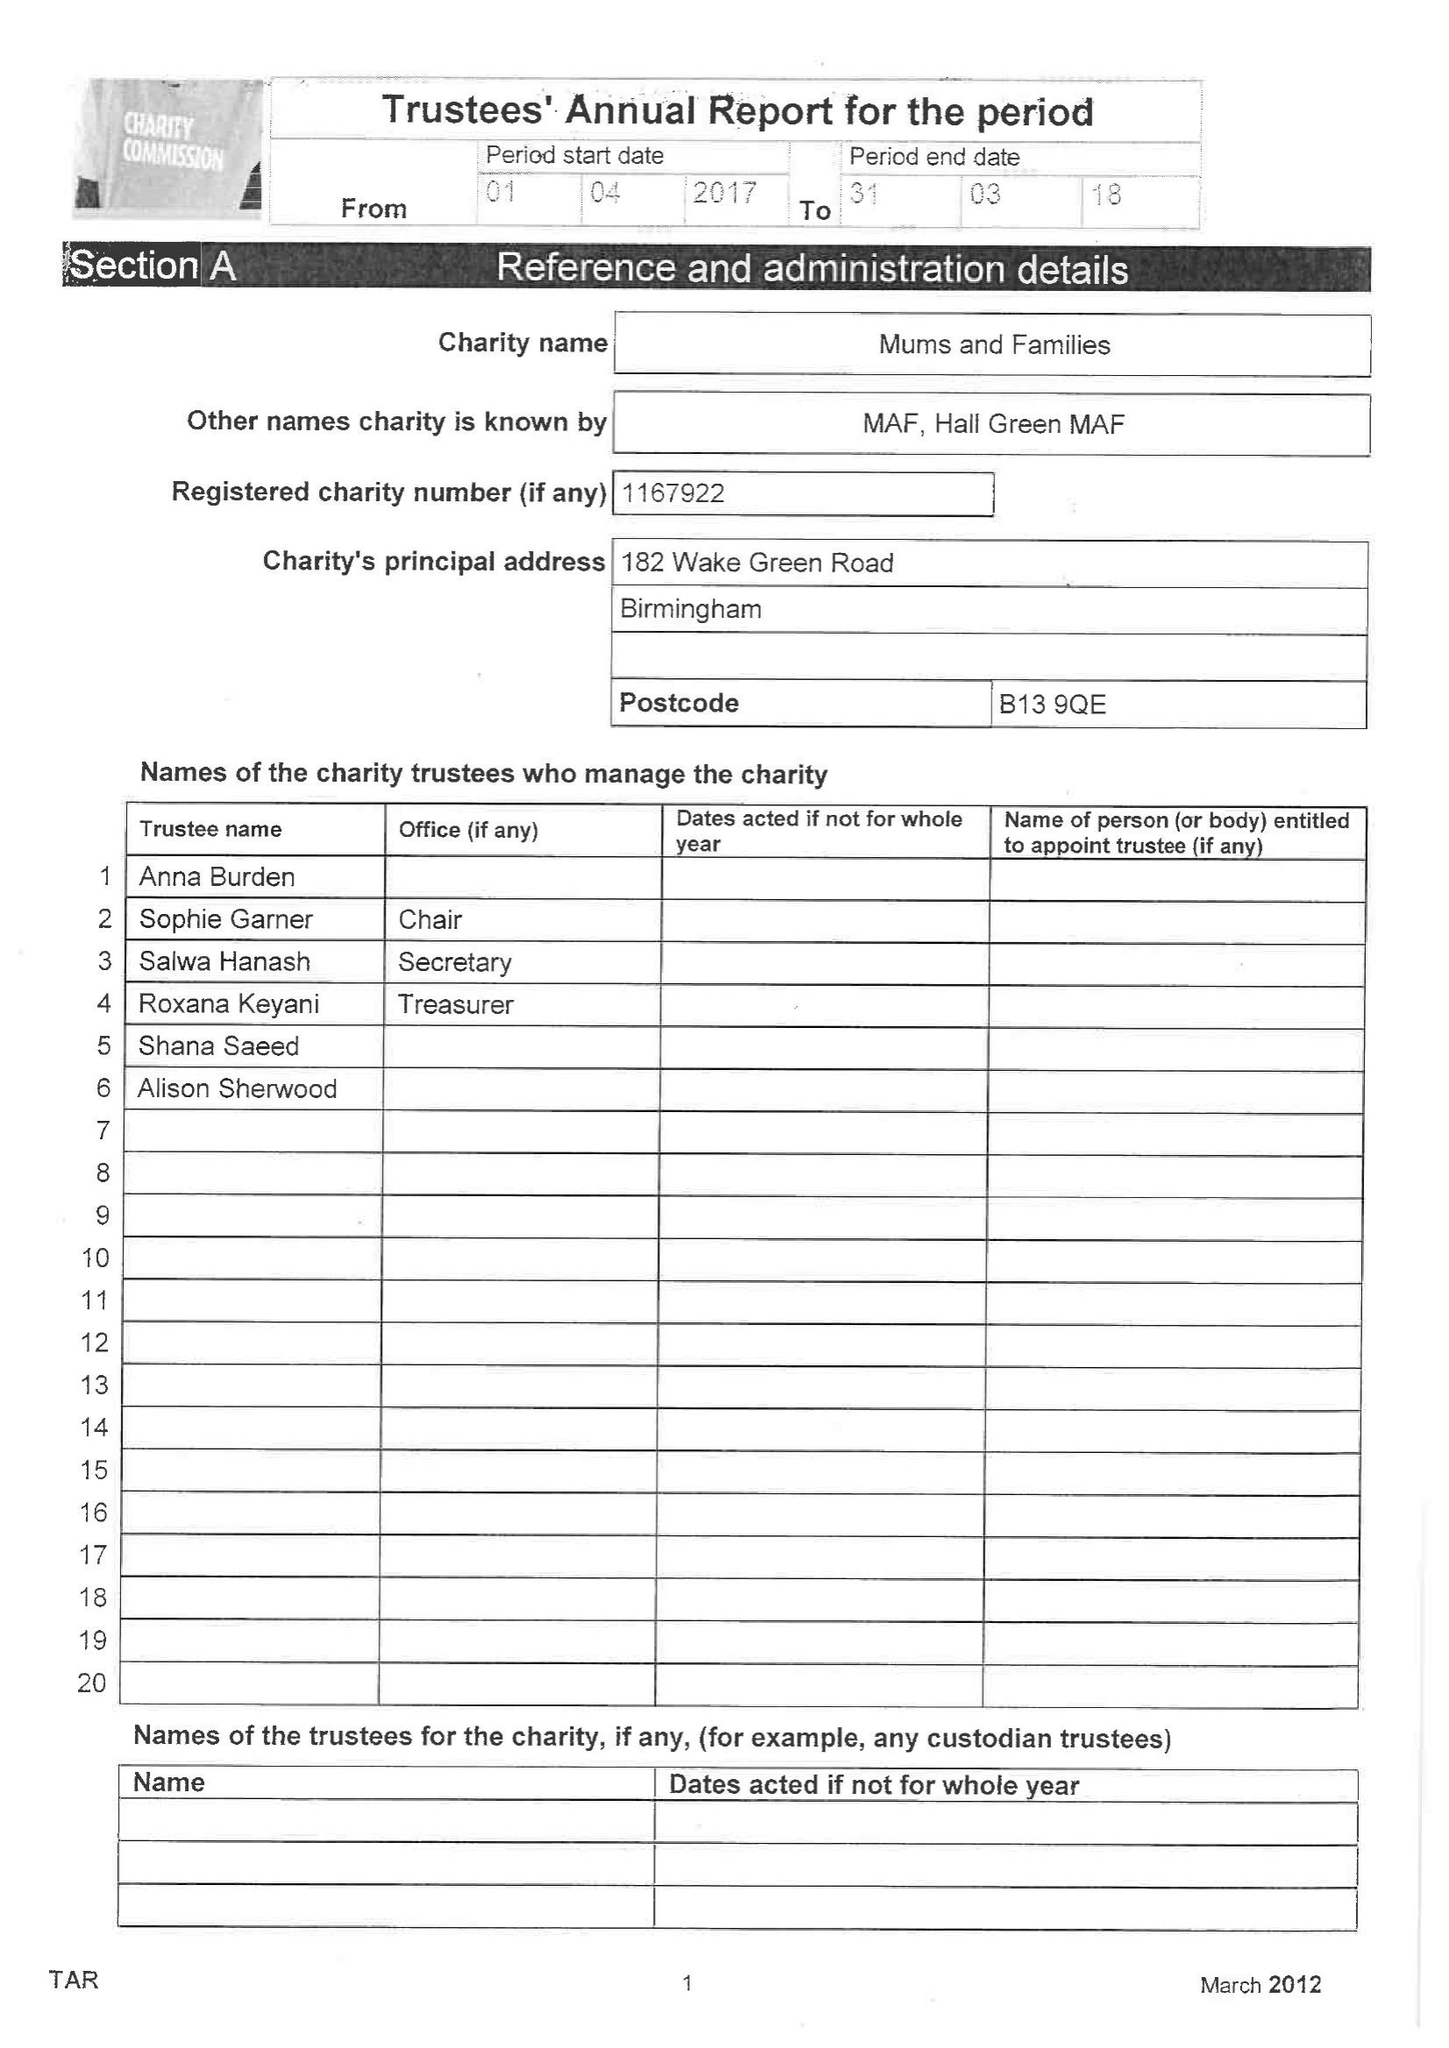What is the value for the report_date?
Answer the question using a single word or phrase. 2018-03-31 